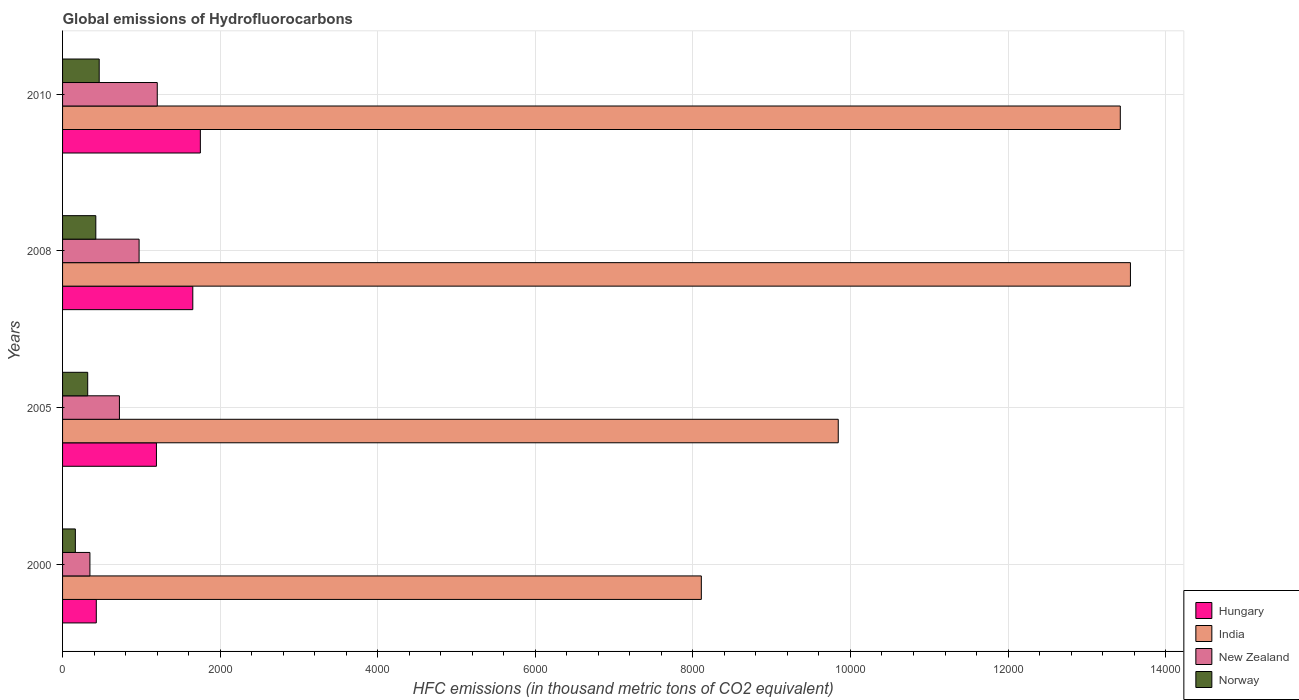How many different coloured bars are there?
Keep it short and to the point. 4. Are the number of bars per tick equal to the number of legend labels?
Keep it short and to the point. Yes. How many bars are there on the 1st tick from the bottom?
Provide a succinct answer. 4. What is the label of the 4th group of bars from the top?
Your answer should be very brief. 2000. In how many cases, is the number of bars for a given year not equal to the number of legend labels?
Your response must be concise. 0. What is the global emissions of Hydrofluorocarbons in New Zealand in 2010?
Give a very brief answer. 1202. Across all years, what is the maximum global emissions of Hydrofluorocarbons in Hungary?
Provide a succinct answer. 1749. Across all years, what is the minimum global emissions of Hydrofluorocarbons in Norway?
Offer a terse response. 162.3. In which year was the global emissions of Hydrofluorocarbons in New Zealand maximum?
Your answer should be very brief. 2010. In which year was the global emissions of Hydrofluorocarbons in Norway minimum?
Provide a succinct answer. 2000. What is the total global emissions of Hydrofluorocarbons in New Zealand in the graph?
Your answer should be very brief. 3242.4. What is the difference between the global emissions of Hydrofluorocarbons in Hungary in 2005 and that in 2008?
Your answer should be very brief. -461.5. What is the difference between the global emissions of Hydrofluorocarbons in New Zealand in 2010 and the global emissions of Hydrofluorocarbons in Norway in 2005?
Make the answer very short. 883. What is the average global emissions of Hydrofluorocarbons in New Zealand per year?
Your response must be concise. 810.6. In the year 2010, what is the difference between the global emissions of Hydrofluorocarbons in India and global emissions of Hydrofluorocarbons in Norway?
Keep it short and to the point. 1.30e+04. What is the ratio of the global emissions of Hydrofluorocarbons in Hungary in 2008 to that in 2010?
Your answer should be very brief. 0.95. Is the difference between the global emissions of Hydrofluorocarbons in India in 2005 and 2008 greater than the difference between the global emissions of Hydrofluorocarbons in Norway in 2005 and 2008?
Provide a short and direct response. No. What is the difference between the highest and the second highest global emissions of Hydrofluorocarbons in Hungary?
Ensure brevity in your answer.  96.1. What is the difference between the highest and the lowest global emissions of Hydrofluorocarbons in New Zealand?
Provide a succinct answer. 854.7. In how many years, is the global emissions of Hydrofluorocarbons in Hungary greater than the average global emissions of Hydrofluorocarbons in Hungary taken over all years?
Offer a very short reply. 2. Is it the case that in every year, the sum of the global emissions of Hydrofluorocarbons in Norway and global emissions of Hydrofluorocarbons in Hungary is greater than the sum of global emissions of Hydrofluorocarbons in New Zealand and global emissions of Hydrofluorocarbons in India?
Offer a very short reply. No. What does the 3rd bar from the top in 2008 represents?
Offer a very short reply. India. What does the 1st bar from the bottom in 2010 represents?
Offer a terse response. Hungary. Is it the case that in every year, the sum of the global emissions of Hydrofluorocarbons in Hungary and global emissions of Hydrofluorocarbons in Norway is greater than the global emissions of Hydrofluorocarbons in India?
Your answer should be very brief. No. How many bars are there?
Make the answer very short. 16. Are all the bars in the graph horizontal?
Offer a terse response. Yes. How many years are there in the graph?
Your answer should be compact. 4. What is the difference between two consecutive major ticks on the X-axis?
Keep it short and to the point. 2000. Does the graph contain any zero values?
Your answer should be very brief. No. Does the graph contain grids?
Make the answer very short. Yes. Where does the legend appear in the graph?
Offer a terse response. Bottom right. How many legend labels are there?
Offer a very short reply. 4. What is the title of the graph?
Your answer should be compact. Global emissions of Hydrofluorocarbons. Does "Poland" appear as one of the legend labels in the graph?
Ensure brevity in your answer.  No. What is the label or title of the X-axis?
Your answer should be very brief. HFC emissions (in thousand metric tons of CO2 equivalent). What is the HFC emissions (in thousand metric tons of CO2 equivalent) of Hungary in 2000?
Provide a short and direct response. 428.2. What is the HFC emissions (in thousand metric tons of CO2 equivalent) of India in 2000?
Your response must be concise. 8107.2. What is the HFC emissions (in thousand metric tons of CO2 equivalent) of New Zealand in 2000?
Your answer should be very brief. 347.3. What is the HFC emissions (in thousand metric tons of CO2 equivalent) of Norway in 2000?
Offer a very short reply. 162.3. What is the HFC emissions (in thousand metric tons of CO2 equivalent) in Hungary in 2005?
Provide a short and direct response. 1191.4. What is the HFC emissions (in thousand metric tons of CO2 equivalent) of India in 2005?
Offer a very short reply. 9845.2. What is the HFC emissions (in thousand metric tons of CO2 equivalent) of New Zealand in 2005?
Your answer should be compact. 721.7. What is the HFC emissions (in thousand metric tons of CO2 equivalent) in Norway in 2005?
Your response must be concise. 319. What is the HFC emissions (in thousand metric tons of CO2 equivalent) of Hungary in 2008?
Ensure brevity in your answer.  1652.9. What is the HFC emissions (in thousand metric tons of CO2 equivalent) in India in 2008?
Provide a succinct answer. 1.36e+04. What is the HFC emissions (in thousand metric tons of CO2 equivalent) of New Zealand in 2008?
Give a very brief answer. 971.4. What is the HFC emissions (in thousand metric tons of CO2 equivalent) of Norway in 2008?
Offer a terse response. 422. What is the HFC emissions (in thousand metric tons of CO2 equivalent) in Hungary in 2010?
Ensure brevity in your answer.  1749. What is the HFC emissions (in thousand metric tons of CO2 equivalent) of India in 2010?
Keep it short and to the point. 1.34e+04. What is the HFC emissions (in thousand metric tons of CO2 equivalent) in New Zealand in 2010?
Keep it short and to the point. 1202. What is the HFC emissions (in thousand metric tons of CO2 equivalent) in Norway in 2010?
Provide a short and direct response. 465. Across all years, what is the maximum HFC emissions (in thousand metric tons of CO2 equivalent) of Hungary?
Provide a succinct answer. 1749. Across all years, what is the maximum HFC emissions (in thousand metric tons of CO2 equivalent) of India?
Make the answer very short. 1.36e+04. Across all years, what is the maximum HFC emissions (in thousand metric tons of CO2 equivalent) in New Zealand?
Provide a short and direct response. 1202. Across all years, what is the maximum HFC emissions (in thousand metric tons of CO2 equivalent) in Norway?
Provide a short and direct response. 465. Across all years, what is the minimum HFC emissions (in thousand metric tons of CO2 equivalent) in Hungary?
Ensure brevity in your answer.  428.2. Across all years, what is the minimum HFC emissions (in thousand metric tons of CO2 equivalent) of India?
Ensure brevity in your answer.  8107.2. Across all years, what is the minimum HFC emissions (in thousand metric tons of CO2 equivalent) of New Zealand?
Ensure brevity in your answer.  347.3. Across all years, what is the minimum HFC emissions (in thousand metric tons of CO2 equivalent) of Norway?
Make the answer very short. 162.3. What is the total HFC emissions (in thousand metric tons of CO2 equivalent) in Hungary in the graph?
Ensure brevity in your answer.  5021.5. What is the total HFC emissions (in thousand metric tons of CO2 equivalent) in India in the graph?
Make the answer very short. 4.49e+04. What is the total HFC emissions (in thousand metric tons of CO2 equivalent) of New Zealand in the graph?
Keep it short and to the point. 3242.4. What is the total HFC emissions (in thousand metric tons of CO2 equivalent) in Norway in the graph?
Provide a succinct answer. 1368.3. What is the difference between the HFC emissions (in thousand metric tons of CO2 equivalent) in Hungary in 2000 and that in 2005?
Your answer should be compact. -763.2. What is the difference between the HFC emissions (in thousand metric tons of CO2 equivalent) in India in 2000 and that in 2005?
Provide a short and direct response. -1738. What is the difference between the HFC emissions (in thousand metric tons of CO2 equivalent) in New Zealand in 2000 and that in 2005?
Your answer should be very brief. -374.4. What is the difference between the HFC emissions (in thousand metric tons of CO2 equivalent) in Norway in 2000 and that in 2005?
Your answer should be very brief. -156.7. What is the difference between the HFC emissions (in thousand metric tons of CO2 equivalent) in Hungary in 2000 and that in 2008?
Offer a very short reply. -1224.7. What is the difference between the HFC emissions (in thousand metric tons of CO2 equivalent) in India in 2000 and that in 2008?
Make the answer very short. -5446.5. What is the difference between the HFC emissions (in thousand metric tons of CO2 equivalent) in New Zealand in 2000 and that in 2008?
Make the answer very short. -624.1. What is the difference between the HFC emissions (in thousand metric tons of CO2 equivalent) in Norway in 2000 and that in 2008?
Offer a terse response. -259.7. What is the difference between the HFC emissions (in thousand metric tons of CO2 equivalent) of Hungary in 2000 and that in 2010?
Your answer should be very brief. -1320.8. What is the difference between the HFC emissions (in thousand metric tons of CO2 equivalent) of India in 2000 and that in 2010?
Give a very brief answer. -5317.8. What is the difference between the HFC emissions (in thousand metric tons of CO2 equivalent) in New Zealand in 2000 and that in 2010?
Ensure brevity in your answer.  -854.7. What is the difference between the HFC emissions (in thousand metric tons of CO2 equivalent) of Norway in 2000 and that in 2010?
Your response must be concise. -302.7. What is the difference between the HFC emissions (in thousand metric tons of CO2 equivalent) in Hungary in 2005 and that in 2008?
Provide a succinct answer. -461.5. What is the difference between the HFC emissions (in thousand metric tons of CO2 equivalent) in India in 2005 and that in 2008?
Keep it short and to the point. -3708.5. What is the difference between the HFC emissions (in thousand metric tons of CO2 equivalent) in New Zealand in 2005 and that in 2008?
Your response must be concise. -249.7. What is the difference between the HFC emissions (in thousand metric tons of CO2 equivalent) in Norway in 2005 and that in 2008?
Your response must be concise. -103. What is the difference between the HFC emissions (in thousand metric tons of CO2 equivalent) in Hungary in 2005 and that in 2010?
Make the answer very short. -557.6. What is the difference between the HFC emissions (in thousand metric tons of CO2 equivalent) of India in 2005 and that in 2010?
Your response must be concise. -3579.8. What is the difference between the HFC emissions (in thousand metric tons of CO2 equivalent) of New Zealand in 2005 and that in 2010?
Provide a succinct answer. -480.3. What is the difference between the HFC emissions (in thousand metric tons of CO2 equivalent) of Norway in 2005 and that in 2010?
Your answer should be very brief. -146. What is the difference between the HFC emissions (in thousand metric tons of CO2 equivalent) in Hungary in 2008 and that in 2010?
Your response must be concise. -96.1. What is the difference between the HFC emissions (in thousand metric tons of CO2 equivalent) of India in 2008 and that in 2010?
Provide a short and direct response. 128.7. What is the difference between the HFC emissions (in thousand metric tons of CO2 equivalent) in New Zealand in 2008 and that in 2010?
Ensure brevity in your answer.  -230.6. What is the difference between the HFC emissions (in thousand metric tons of CO2 equivalent) of Norway in 2008 and that in 2010?
Give a very brief answer. -43. What is the difference between the HFC emissions (in thousand metric tons of CO2 equivalent) of Hungary in 2000 and the HFC emissions (in thousand metric tons of CO2 equivalent) of India in 2005?
Ensure brevity in your answer.  -9417. What is the difference between the HFC emissions (in thousand metric tons of CO2 equivalent) of Hungary in 2000 and the HFC emissions (in thousand metric tons of CO2 equivalent) of New Zealand in 2005?
Your response must be concise. -293.5. What is the difference between the HFC emissions (in thousand metric tons of CO2 equivalent) in Hungary in 2000 and the HFC emissions (in thousand metric tons of CO2 equivalent) in Norway in 2005?
Your answer should be very brief. 109.2. What is the difference between the HFC emissions (in thousand metric tons of CO2 equivalent) in India in 2000 and the HFC emissions (in thousand metric tons of CO2 equivalent) in New Zealand in 2005?
Your answer should be compact. 7385.5. What is the difference between the HFC emissions (in thousand metric tons of CO2 equivalent) of India in 2000 and the HFC emissions (in thousand metric tons of CO2 equivalent) of Norway in 2005?
Offer a very short reply. 7788.2. What is the difference between the HFC emissions (in thousand metric tons of CO2 equivalent) in New Zealand in 2000 and the HFC emissions (in thousand metric tons of CO2 equivalent) in Norway in 2005?
Provide a short and direct response. 28.3. What is the difference between the HFC emissions (in thousand metric tons of CO2 equivalent) in Hungary in 2000 and the HFC emissions (in thousand metric tons of CO2 equivalent) in India in 2008?
Keep it short and to the point. -1.31e+04. What is the difference between the HFC emissions (in thousand metric tons of CO2 equivalent) in Hungary in 2000 and the HFC emissions (in thousand metric tons of CO2 equivalent) in New Zealand in 2008?
Offer a very short reply. -543.2. What is the difference between the HFC emissions (in thousand metric tons of CO2 equivalent) of India in 2000 and the HFC emissions (in thousand metric tons of CO2 equivalent) of New Zealand in 2008?
Provide a succinct answer. 7135.8. What is the difference between the HFC emissions (in thousand metric tons of CO2 equivalent) of India in 2000 and the HFC emissions (in thousand metric tons of CO2 equivalent) of Norway in 2008?
Your answer should be very brief. 7685.2. What is the difference between the HFC emissions (in thousand metric tons of CO2 equivalent) in New Zealand in 2000 and the HFC emissions (in thousand metric tons of CO2 equivalent) in Norway in 2008?
Offer a terse response. -74.7. What is the difference between the HFC emissions (in thousand metric tons of CO2 equivalent) of Hungary in 2000 and the HFC emissions (in thousand metric tons of CO2 equivalent) of India in 2010?
Offer a very short reply. -1.30e+04. What is the difference between the HFC emissions (in thousand metric tons of CO2 equivalent) in Hungary in 2000 and the HFC emissions (in thousand metric tons of CO2 equivalent) in New Zealand in 2010?
Make the answer very short. -773.8. What is the difference between the HFC emissions (in thousand metric tons of CO2 equivalent) of Hungary in 2000 and the HFC emissions (in thousand metric tons of CO2 equivalent) of Norway in 2010?
Your answer should be compact. -36.8. What is the difference between the HFC emissions (in thousand metric tons of CO2 equivalent) in India in 2000 and the HFC emissions (in thousand metric tons of CO2 equivalent) in New Zealand in 2010?
Make the answer very short. 6905.2. What is the difference between the HFC emissions (in thousand metric tons of CO2 equivalent) of India in 2000 and the HFC emissions (in thousand metric tons of CO2 equivalent) of Norway in 2010?
Ensure brevity in your answer.  7642.2. What is the difference between the HFC emissions (in thousand metric tons of CO2 equivalent) in New Zealand in 2000 and the HFC emissions (in thousand metric tons of CO2 equivalent) in Norway in 2010?
Give a very brief answer. -117.7. What is the difference between the HFC emissions (in thousand metric tons of CO2 equivalent) of Hungary in 2005 and the HFC emissions (in thousand metric tons of CO2 equivalent) of India in 2008?
Give a very brief answer. -1.24e+04. What is the difference between the HFC emissions (in thousand metric tons of CO2 equivalent) in Hungary in 2005 and the HFC emissions (in thousand metric tons of CO2 equivalent) in New Zealand in 2008?
Offer a terse response. 220. What is the difference between the HFC emissions (in thousand metric tons of CO2 equivalent) of Hungary in 2005 and the HFC emissions (in thousand metric tons of CO2 equivalent) of Norway in 2008?
Make the answer very short. 769.4. What is the difference between the HFC emissions (in thousand metric tons of CO2 equivalent) of India in 2005 and the HFC emissions (in thousand metric tons of CO2 equivalent) of New Zealand in 2008?
Make the answer very short. 8873.8. What is the difference between the HFC emissions (in thousand metric tons of CO2 equivalent) in India in 2005 and the HFC emissions (in thousand metric tons of CO2 equivalent) in Norway in 2008?
Provide a short and direct response. 9423.2. What is the difference between the HFC emissions (in thousand metric tons of CO2 equivalent) in New Zealand in 2005 and the HFC emissions (in thousand metric tons of CO2 equivalent) in Norway in 2008?
Your answer should be very brief. 299.7. What is the difference between the HFC emissions (in thousand metric tons of CO2 equivalent) in Hungary in 2005 and the HFC emissions (in thousand metric tons of CO2 equivalent) in India in 2010?
Make the answer very short. -1.22e+04. What is the difference between the HFC emissions (in thousand metric tons of CO2 equivalent) of Hungary in 2005 and the HFC emissions (in thousand metric tons of CO2 equivalent) of New Zealand in 2010?
Your answer should be compact. -10.6. What is the difference between the HFC emissions (in thousand metric tons of CO2 equivalent) of Hungary in 2005 and the HFC emissions (in thousand metric tons of CO2 equivalent) of Norway in 2010?
Make the answer very short. 726.4. What is the difference between the HFC emissions (in thousand metric tons of CO2 equivalent) of India in 2005 and the HFC emissions (in thousand metric tons of CO2 equivalent) of New Zealand in 2010?
Your answer should be very brief. 8643.2. What is the difference between the HFC emissions (in thousand metric tons of CO2 equivalent) of India in 2005 and the HFC emissions (in thousand metric tons of CO2 equivalent) of Norway in 2010?
Offer a very short reply. 9380.2. What is the difference between the HFC emissions (in thousand metric tons of CO2 equivalent) in New Zealand in 2005 and the HFC emissions (in thousand metric tons of CO2 equivalent) in Norway in 2010?
Provide a short and direct response. 256.7. What is the difference between the HFC emissions (in thousand metric tons of CO2 equivalent) in Hungary in 2008 and the HFC emissions (in thousand metric tons of CO2 equivalent) in India in 2010?
Keep it short and to the point. -1.18e+04. What is the difference between the HFC emissions (in thousand metric tons of CO2 equivalent) of Hungary in 2008 and the HFC emissions (in thousand metric tons of CO2 equivalent) of New Zealand in 2010?
Offer a terse response. 450.9. What is the difference between the HFC emissions (in thousand metric tons of CO2 equivalent) in Hungary in 2008 and the HFC emissions (in thousand metric tons of CO2 equivalent) in Norway in 2010?
Offer a very short reply. 1187.9. What is the difference between the HFC emissions (in thousand metric tons of CO2 equivalent) in India in 2008 and the HFC emissions (in thousand metric tons of CO2 equivalent) in New Zealand in 2010?
Your answer should be compact. 1.24e+04. What is the difference between the HFC emissions (in thousand metric tons of CO2 equivalent) in India in 2008 and the HFC emissions (in thousand metric tons of CO2 equivalent) in Norway in 2010?
Give a very brief answer. 1.31e+04. What is the difference between the HFC emissions (in thousand metric tons of CO2 equivalent) in New Zealand in 2008 and the HFC emissions (in thousand metric tons of CO2 equivalent) in Norway in 2010?
Offer a very short reply. 506.4. What is the average HFC emissions (in thousand metric tons of CO2 equivalent) in Hungary per year?
Make the answer very short. 1255.38. What is the average HFC emissions (in thousand metric tons of CO2 equivalent) of India per year?
Ensure brevity in your answer.  1.12e+04. What is the average HFC emissions (in thousand metric tons of CO2 equivalent) in New Zealand per year?
Offer a terse response. 810.6. What is the average HFC emissions (in thousand metric tons of CO2 equivalent) in Norway per year?
Keep it short and to the point. 342.07. In the year 2000, what is the difference between the HFC emissions (in thousand metric tons of CO2 equivalent) in Hungary and HFC emissions (in thousand metric tons of CO2 equivalent) in India?
Provide a succinct answer. -7679. In the year 2000, what is the difference between the HFC emissions (in thousand metric tons of CO2 equivalent) of Hungary and HFC emissions (in thousand metric tons of CO2 equivalent) of New Zealand?
Your answer should be very brief. 80.9. In the year 2000, what is the difference between the HFC emissions (in thousand metric tons of CO2 equivalent) in Hungary and HFC emissions (in thousand metric tons of CO2 equivalent) in Norway?
Offer a very short reply. 265.9. In the year 2000, what is the difference between the HFC emissions (in thousand metric tons of CO2 equivalent) of India and HFC emissions (in thousand metric tons of CO2 equivalent) of New Zealand?
Provide a short and direct response. 7759.9. In the year 2000, what is the difference between the HFC emissions (in thousand metric tons of CO2 equivalent) in India and HFC emissions (in thousand metric tons of CO2 equivalent) in Norway?
Ensure brevity in your answer.  7944.9. In the year 2000, what is the difference between the HFC emissions (in thousand metric tons of CO2 equivalent) in New Zealand and HFC emissions (in thousand metric tons of CO2 equivalent) in Norway?
Your response must be concise. 185. In the year 2005, what is the difference between the HFC emissions (in thousand metric tons of CO2 equivalent) of Hungary and HFC emissions (in thousand metric tons of CO2 equivalent) of India?
Provide a succinct answer. -8653.8. In the year 2005, what is the difference between the HFC emissions (in thousand metric tons of CO2 equivalent) in Hungary and HFC emissions (in thousand metric tons of CO2 equivalent) in New Zealand?
Your answer should be very brief. 469.7. In the year 2005, what is the difference between the HFC emissions (in thousand metric tons of CO2 equivalent) of Hungary and HFC emissions (in thousand metric tons of CO2 equivalent) of Norway?
Your answer should be very brief. 872.4. In the year 2005, what is the difference between the HFC emissions (in thousand metric tons of CO2 equivalent) in India and HFC emissions (in thousand metric tons of CO2 equivalent) in New Zealand?
Ensure brevity in your answer.  9123.5. In the year 2005, what is the difference between the HFC emissions (in thousand metric tons of CO2 equivalent) in India and HFC emissions (in thousand metric tons of CO2 equivalent) in Norway?
Provide a succinct answer. 9526.2. In the year 2005, what is the difference between the HFC emissions (in thousand metric tons of CO2 equivalent) of New Zealand and HFC emissions (in thousand metric tons of CO2 equivalent) of Norway?
Provide a short and direct response. 402.7. In the year 2008, what is the difference between the HFC emissions (in thousand metric tons of CO2 equivalent) of Hungary and HFC emissions (in thousand metric tons of CO2 equivalent) of India?
Keep it short and to the point. -1.19e+04. In the year 2008, what is the difference between the HFC emissions (in thousand metric tons of CO2 equivalent) in Hungary and HFC emissions (in thousand metric tons of CO2 equivalent) in New Zealand?
Offer a terse response. 681.5. In the year 2008, what is the difference between the HFC emissions (in thousand metric tons of CO2 equivalent) of Hungary and HFC emissions (in thousand metric tons of CO2 equivalent) of Norway?
Provide a succinct answer. 1230.9. In the year 2008, what is the difference between the HFC emissions (in thousand metric tons of CO2 equivalent) in India and HFC emissions (in thousand metric tons of CO2 equivalent) in New Zealand?
Provide a succinct answer. 1.26e+04. In the year 2008, what is the difference between the HFC emissions (in thousand metric tons of CO2 equivalent) in India and HFC emissions (in thousand metric tons of CO2 equivalent) in Norway?
Offer a very short reply. 1.31e+04. In the year 2008, what is the difference between the HFC emissions (in thousand metric tons of CO2 equivalent) in New Zealand and HFC emissions (in thousand metric tons of CO2 equivalent) in Norway?
Make the answer very short. 549.4. In the year 2010, what is the difference between the HFC emissions (in thousand metric tons of CO2 equivalent) of Hungary and HFC emissions (in thousand metric tons of CO2 equivalent) of India?
Provide a short and direct response. -1.17e+04. In the year 2010, what is the difference between the HFC emissions (in thousand metric tons of CO2 equivalent) of Hungary and HFC emissions (in thousand metric tons of CO2 equivalent) of New Zealand?
Offer a terse response. 547. In the year 2010, what is the difference between the HFC emissions (in thousand metric tons of CO2 equivalent) of Hungary and HFC emissions (in thousand metric tons of CO2 equivalent) of Norway?
Your answer should be very brief. 1284. In the year 2010, what is the difference between the HFC emissions (in thousand metric tons of CO2 equivalent) of India and HFC emissions (in thousand metric tons of CO2 equivalent) of New Zealand?
Your response must be concise. 1.22e+04. In the year 2010, what is the difference between the HFC emissions (in thousand metric tons of CO2 equivalent) of India and HFC emissions (in thousand metric tons of CO2 equivalent) of Norway?
Provide a succinct answer. 1.30e+04. In the year 2010, what is the difference between the HFC emissions (in thousand metric tons of CO2 equivalent) of New Zealand and HFC emissions (in thousand metric tons of CO2 equivalent) of Norway?
Offer a very short reply. 737. What is the ratio of the HFC emissions (in thousand metric tons of CO2 equivalent) of Hungary in 2000 to that in 2005?
Offer a very short reply. 0.36. What is the ratio of the HFC emissions (in thousand metric tons of CO2 equivalent) in India in 2000 to that in 2005?
Ensure brevity in your answer.  0.82. What is the ratio of the HFC emissions (in thousand metric tons of CO2 equivalent) in New Zealand in 2000 to that in 2005?
Make the answer very short. 0.48. What is the ratio of the HFC emissions (in thousand metric tons of CO2 equivalent) in Norway in 2000 to that in 2005?
Your answer should be compact. 0.51. What is the ratio of the HFC emissions (in thousand metric tons of CO2 equivalent) of Hungary in 2000 to that in 2008?
Ensure brevity in your answer.  0.26. What is the ratio of the HFC emissions (in thousand metric tons of CO2 equivalent) in India in 2000 to that in 2008?
Your answer should be very brief. 0.6. What is the ratio of the HFC emissions (in thousand metric tons of CO2 equivalent) of New Zealand in 2000 to that in 2008?
Your answer should be compact. 0.36. What is the ratio of the HFC emissions (in thousand metric tons of CO2 equivalent) in Norway in 2000 to that in 2008?
Offer a terse response. 0.38. What is the ratio of the HFC emissions (in thousand metric tons of CO2 equivalent) of Hungary in 2000 to that in 2010?
Provide a succinct answer. 0.24. What is the ratio of the HFC emissions (in thousand metric tons of CO2 equivalent) in India in 2000 to that in 2010?
Provide a short and direct response. 0.6. What is the ratio of the HFC emissions (in thousand metric tons of CO2 equivalent) in New Zealand in 2000 to that in 2010?
Provide a succinct answer. 0.29. What is the ratio of the HFC emissions (in thousand metric tons of CO2 equivalent) of Norway in 2000 to that in 2010?
Your answer should be very brief. 0.35. What is the ratio of the HFC emissions (in thousand metric tons of CO2 equivalent) in Hungary in 2005 to that in 2008?
Ensure brevity in your answer.  0.72. What is the ratio of the HFC emissions (in thousand metric tons of CO2 equivalent) in India in 2005 to that in 2008?
Offer a very short reply. 0.73. What is the ratio of the HFC emissions (in thousand metric tons of CO2 equivalent) in New Zealand in 2005 to that in 2008?
Provide a short and direct response. 0.74. What is the ratio of the HFC emissions (in thousand metric tons of CO2 equivalent) of Norway in 2005 to that in 2008?
Offer a very short reply. 0.76. What is the ratio of the HFC emissions (in thousand metric tons of CO2 equivalent) in Hungary in 2005 to that in 2010?
Your answer should be very brief. 0.68. What is the ratio of the HFC emissions (in thousand metric tons of CO2 equivalent) in India in 2005 to that in 2010?
Your response must be concise. 0.73. What is the ratio of the HFC emissions (in thousand metric tons of CO2 equivalent) of New Zealand in 2005 to that in 2010?
Keep it short and to the point. 0.6. What is the ratio of the HFC emissions (in thousand metric tons of CO2 equivalent) in Norway in 2005 to that in 2010?
Provide a short and direct response. 0.69. What is the ratio of the HFC emissions (in thousand metric tons of CO2 equivalent) in Hungary in 2008 to that in 2010?
Your response must be concise. 0.95. What is the ratio of the HFC emissions (in thousand metric tons of CO2 equivalent) in India in 2008 to that in 2010?
Offer a terse response. 1.01. What is the ratio of the HFC emissions (in thousand metric tons of CO2 equivalent) of New Zealand in 2008 to that in 2010?
Offer a very short reply. 0.81. What is the ratio of the HFC emissions (in thousand metric tons of CO2 equivalent) in Norway in 2008 to that in 2010?
Keep it short and to the point. 0.91. What is the difference between the highest and the second highest HFC emissions (in thousand metric tons of CO2 equivalent) of Hungary?
Offer a very short reply. 96.1. What is the difference between the highest and the second highest HFC emissions (in thousand metric tons of CO2 equivalent) of India?
Your response must be concise. 128.7. What is the difference between the highest and the second highest HFC emissions (in thousand metric tons of CO2 equivalent) in New Zealand?
Offer a very short reply. 230.6. What is the difference between the highest and the lowest HFC emissions (in thousand metric tons of CO2 equivalent) of Hungary?
Provide a succinct answer. 1320.8. What is the difference between the highest and the lowest HFC emissions (in thousand metric tons of CO2 equivalent) of India?
Your response must be concise. 5446.5. What is the difference between the highest and the lowest HFC emissions (in thousand metric tons of CO2 equivalent) in New Zealand?
Make the answer very short. 854.7. What is the difference between the highest and the lowest HFC emissions (in thousand metric tons of CO2 equivalent) in Norway?
Your answer should be very brief. 302.7. 